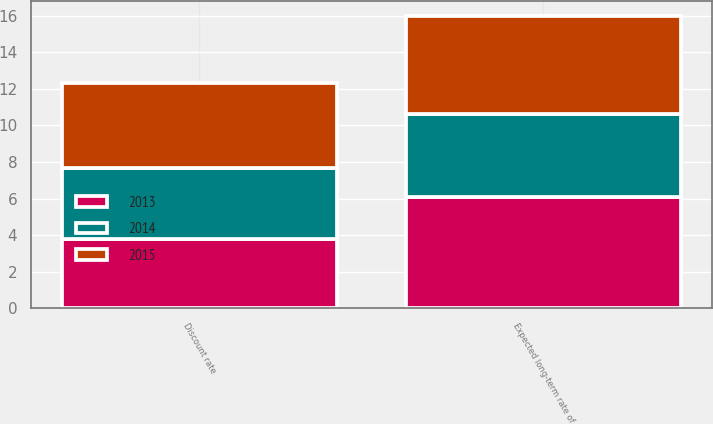<chart> <loc_0><loc_0><loc_500><loc_500><stacked_bar_chart><ecel><fcel>Discount rate<fcel>Expected long-term rate of<nl><fcel>2013<fcel>3.8<fcel>6.1<nl><fcel>2015<fcel>4.6<fcel>5.4<nl><fcel>2014<fcel>3.9<fcel>4.5<nl></chart> 